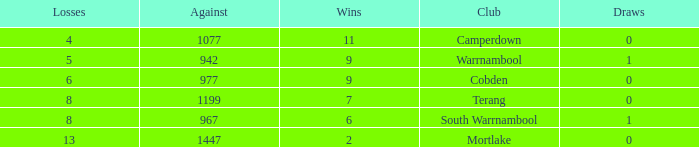What is the draw when the losses were more than 8 and less than 2 wins? None. 